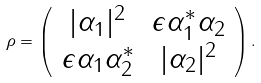Convert formula to latex. <formula><loc_0><loc_0><loc_500><loc_500>\rho = \left ( \begin{array} { c c } | \alpha _ { 1 } | ^ { 2 } & \epsilon \alpha _ { 1 } ^ { * } \alpha _ { 2 } \\ \epsilon \alpha _ { 1 } \alpha _ { 2 } ^ { * } & | \alpha _ { 2 } | ^ { 2 } \end{array} \right ) .</formula> 